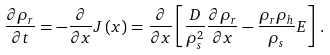<formula> <loc_0><loc_0><loc_500><loc_500>\frac { \partial \rho _ { r } } { \partial t } = - \frac { \partial } { \partial x } J \left ( x \right ) = \frac { \partial } { \partial x } \left [ \frac { D } { \rho _ { s } ^ { 2 } } \frac { \partial \rho _ { r } } { \partial x } - \frac { \rho _ { r } \rho _ { h } } { \rho _ { s } } E \right ] \, .</formula> 